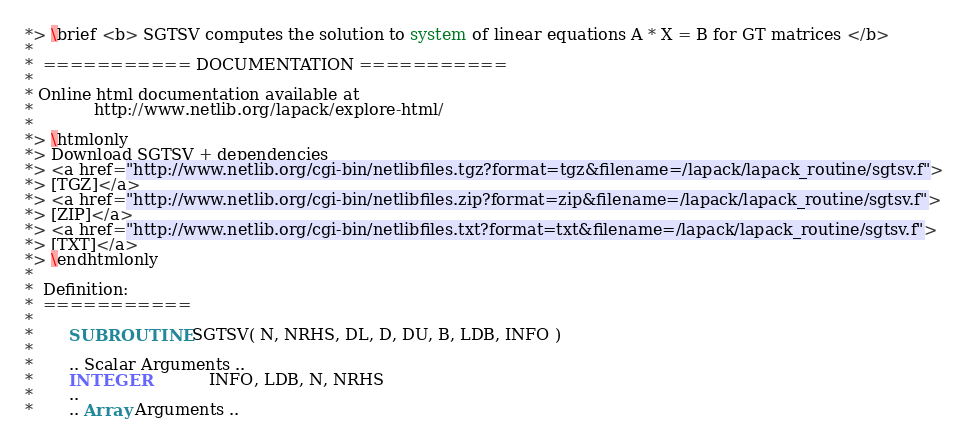<code> <loc_0><loc_0><loc_500><loc_500><_FORTRAN_>*> \brief <b> SGTSV computes the solution to system of linear equations A * X = B for GT matrices </b>
*
*  =========== DOCUMENTATION ===========
*
* Online html documentation available at
*            http://www.netlib.org/lapack/explore-html/
*
*> \htmlonly
*> Download SGTSV + dependencies
*> <a href="http://www.netlib.org/cgi-bin/netlibfiles.tgz?format=tgz&filename=/lapack/lapack_routine/sgtsv.f">
*> [TGZ]</a>
*> <a href="http://www.netlib.org/cgi-bin/netlibfiles.zip?format=zip&filename=/lapack/lapack_routine/sgtsv.f">
*> [ZIP]</a>
*> <a href="http://www.netlib.org/cgi-bin/netlibfiles.txt?format=txt&filename=/lapack/lapack_routine/sgtsv.f">
*> [TXT]</a>
*> \endhtmlonly
*
*  Definition:
*  ===========
*
*       SUBROUTINE SGTSV( N, NRHS, DL, D, DU, B, LDB, INFO )
*
*       .. Scalar Arguments ..
*       INTEGER            INFO, LDB, N, NRHS
*       ..
*       .. Array Arguments ..</code> 